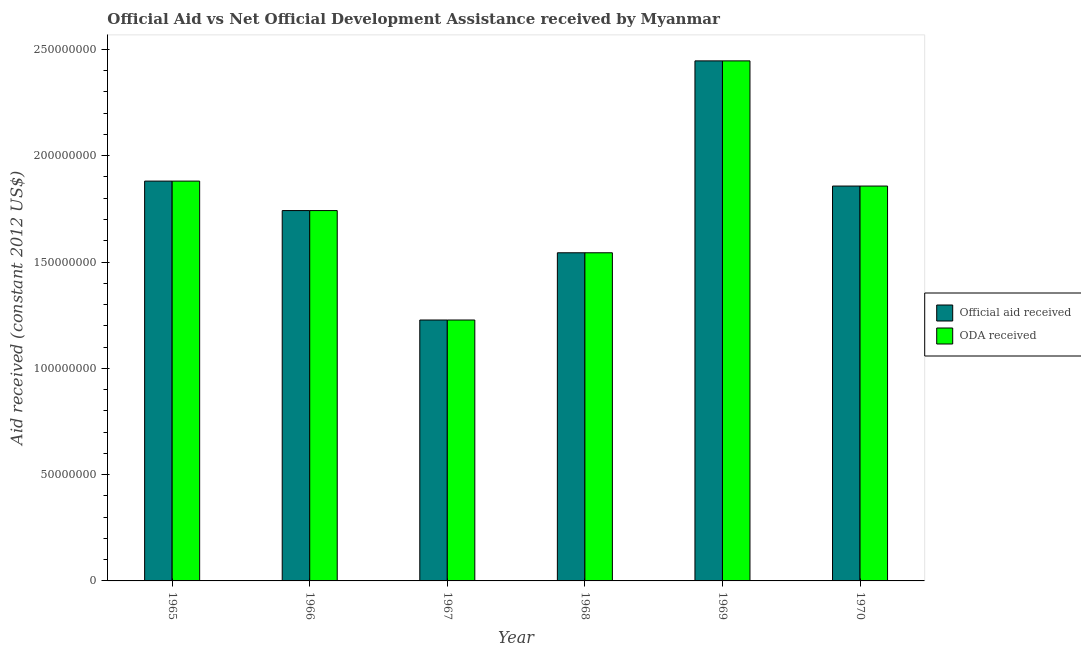How many different coloured bars are there?
Keep it short and to the point. 2. Are the number of bars per tick equal to the number of legend labels?
Your response must be concise. Yes. Are the number of bars on each tick of the X-axis equal?
Your answer should be very brief. Yes. How many bars are there on the 4th tick from the right?
Offer a terse response. 2. What is the label of the 1st group of bars from the left?
Ensure brevity in your answer.  1965. What is the oda received in 1965?
Your answer should be very brief. 1.88e+08. Across all years, what is the maximum official aid received?
Your response must be concise. 2.45e+08. Across all years, what is the minimum official aid received?
Your response must be concise. 1.23e+08. In which year was the official aid received maximum?
Offer a terse response. 1969. In which year was the oda received minimum?
Your answer should be very brief. 1967. What is the total oda received in the graph?
Ensure brevity in your answer.  1.07e+09. What is the difference between the oda received in 1965 and that in 1967?
Your response must be concise. 6.53e+07. What is the difference between the official aid received in 1969 and the oda received in 1967?
Provide a succinct answer. 1.22e+08. What is the average oda received per year?
Make the answer very short. 1.78e+08. In the year 1967, what is the difference between the oda received and official aid received?
Ensure brevity in your answer.  0. In how many years, is the oda received greater than 200000000 US$?
Offer a very short reply. 1. What is the ratio of the oda received in 1967 to that in 1970?
Provide a short and direct response. 0.66. Is the difference between the oda received in 1969 and 1970 greater than the difference between the official aid received in 1969 and 1970?
Keep it short and to the point. No. What is the difference between the highest and the second highest oda received?
Your response must be concise. 5.66e+07. What is the difference between the highest and the lowest official aid received?
Your answer should be compact. 1.22e+08. Is the sum of the oda received in 1966 and 1968 greater than the maximum official aid received across all years?
Keep it short and to the point. Yes. What does the 1st bar from the left in 1966 represents?
Your answer should be very brief. Official aid received. What does the 1st bar from the right in 1969 represents?
Offer a very short reply. ODA received. How many bars are there?
Offer a very short reply. 12. Are all the bars in the graph horizontal?
Provide a succinct answer. No. How many years are there in the graph?
Your answer should be compact. 6. What is the difference between two consecutive major ticks on the Y-axis?
Your answer should be very brief. 5.00e+07. Are the values on the major ticks of Y-axis written in scientific E-notation?
Keep it short and to the point. No. Does the graph contain any zero values?
Your response must be concise. No. Does the graph contain grids?
Make the answer very short. No. How many legend labels are there?
Keep it short and to the point. 2. How are the legend labels stacked?
Offer a terse response. Vertical. What is the title of the graph?
Offer a terse response. Official Aid vs Net Official Development Assistance received by Myanmar . Does "From human activities" appear as one of the legend labels in the graph?
Ensure brevity in your answer.  No. What is the label or title of the X-axis?
Provide a short and direct response. Year. What is the label or title of the Y-axis?
Your answer should be very brief. Aid received (constant 2012 US$). What is the Aid received (constant 2012 US$) in Official aid received in 1965?
Make the answer very short. 1.88e+08. What is the Aid received (constant 2012 US$) in ODA received in 1965?
Provide a short and direct response. 1.88e+08. What is the Aid received (constant 2012 US$) of Official aid received in 1966?
Ensure brevity in your answer.  1.74e+08. What is the Aid received (constant 2012 US$) in ODA received in 1966?
Your answer should be very brief. 1.74e+08. What is the Aid received (constant 2012 US$) of Official aid received in 1967?
Give a very brief answer. 1.23e+08. What is the Aid received (constant 2012 US$) of ODA received in 1967?
Offer a terse response. 1.23e+08. What is the Aid received (constant 2012 US$) of Official aid received in 1968?
Keep it short and to the point. 1.54e+08. What is the Aid received (constant 2012 US$) of ODA received in 1968?
Make the answer very short. 1.54e+08. What is the Aid received (constant 2012 US$) in Official aid received in 1969?
Your response must be concise. 2.45e+08. What is the Aid received (constant 2012 US$) in ODA received in 1969?
Make the answer very short. 2.45e+08. What is the Aid received (constant 2012 US$) in Official aid received in 1970?
Your answer should be compact. 1.86e+08. What is the Aid received (constant 2012 US$) in ODA received in 1970?
Your answer should be very brief. 1.86e+08. Across all years, what is the maximum Aid received (constant 2012 US$) of Official aid received?
Your response must be concise. 2.45e+08. Across all years, what is the maximum Aid received (constant 2012 US$) in ODA received?
Offer a terse response. 2.45e+08. Across all years, what is the minimum Aid received (constant 2012 US$) of Official aid received?
Your answer should be very brief. 1.23e+08. Across all years, what is the minimum Aid received (constant 2012 US$) of ODA received?
Your answer should be very brief. 1.23e+08. What is the total Aid received (constant 2012 US$) in Official aid received in the graph?
Offer a terse response. 1.07e+09. What is the total Aid received (constant 2012 US$) of ODA received in the graph?
Offer a terse response. 1.07e+09. What is the difference between the Aid received (constant 2012 US$) in Official aid received in 1965 and that in 1966?
Give a very brief answer. 1.39e+07. What is the difference between the Aid received (constant 2012 US$) of ODA received in 1965 and that in 1966?
Make the answer very short. 1.39e+07. What is the difference between the Aid received (constant 2012 US$) of Official aid received in 1965 and that in 1967?
Keep it short and to the point. 6.53e+07. What is the difference between the Aid received (constant 2012 US$) of ODA received in 1965 and that in 1967?
Ensure brevity in your answer.  6.53e+07. What is the difference between the Aid received (constant 2012 US$) in Official aid received in 1965 and that in 1968?
Your answer should be compact. 3.37e+07. What is the difference between the Aid received (constant 2012 US$) in ODA received in 1965 and that in 1968?
Give a very brief answer. 3.37e+07. What is the difference between the Aid received (constant 2012 US$) in Official aid received in 1965 and that in 1969?
Ensure brevity in your answer.  -5.66e+07. What is the difference between the Aid received (constant 2012 US$) in ODA received in 1965 and that in 1969?
Offer a very short reply. -5.66e+07. What is the difference between the Aid received (constant 2012 US$) in Official aid received in 1965 and that in 1970?
Your answer should be very brief. 2.33e+06. What is the difference between the Aid received (constant 2012 US$) of ODA received in 1965 and that in 1970?
Ensure brevity in your answer.  2.33e+06. What is the difference between the Aid received (constant 2012 US$) of Official aid received in 1966 and that in 1967?
Provide a succinct answer. 5.15e+07. What is the difference between the Aid received (constant 2012 US$) of ODA received in 1966 and that in 1967?
Give a very brief answer. 5.15e+07. What is the difference between the Aid received (constant 2012 US$) of Official aid received in 1966 and that in 1968?
Your answer should be compact. 1.98e+07. What is the difference between the Aid received (constant 2012 US$) in ODA received in 1966 and that in 1968?
Offer a terse response. 1.98e+07. What is the difference between the Aid received (constant 2012 US$) in Official aid received in 1966 and that in 1969?
Provide a succinct answer. -7.04e+07. What is the difference between the Aid received (constant 2012 US$) in ODA received in 1966 and that in 1969?
Offer a terse response. -7.04e+07. What is the difference between the Aid received (constant 2012 US$) of Official aid received in 1966 and that in 1970?
Offer a terse response. -1.15e+07. What is the difference between the Aid received (constant 2012 US$) of ODA received in 1966 and that in 1970?
Keep it short and to the point. -1.15e+07. What is the difference between the Aid received (constant 2012 US$) in Official aid received in 1967 and that in 1968?
Offer a terse response. -3.16e+07. What is the difference between the Aid received (constant 2012 US$) of ODA received in 1967 and that in 1968?
Give a very brief answer. -3.16e+07. What is the difference between the Aid received (constant 2012 US$) in Official aid received in 1967 and that in 1969?
Offer a very short reply. -1.22e+08. What is the difference between the Aid received (constant 2012 US$) of ODA received in 1967 and that in 1969?
Provide a short and direct response. -1.22e+08. What is the difference between the Aid received (constant 2012 US$) of Official aid received in 1967 and that in 1970?
Your answer should be compact. -6.30e+07. What is the difference between the Aid received (constant 2012 US$) in ODA received in 1967 and that in 1970?
Your response must be concise. -6.30e+07. What is the difference between the Aid received (constant 2012 US$) in Official aid received in 1968 and that in 1969?
Offer a very short reply. -9.03e+07. What is the difference between the Aid received (constant 2012 US$) of ODA received in 1968 and that in 1969?
Your answer should be very brief. -9.03e+07. What is the difference between the Aid received (constant 2012 US$) in Official aid received in 1968 and that in 1970?
Ensure brevity in your answer.  -3.14e+07. What is the difference between the Aid received (constant 2012 US$) in ODA received in 1968 and that in 1970?
Your answer should be very brief. -3.14e+07. What is the difference between the Aid received (constant 2012 US$) of Official aid received in 1969 and that in 1970?
Give a very brief answer. 5.89e+07. What is the difference between the Aid received (constant 2012 US$) of ODA received in 1969 and that in 1970?
Provide a short and direct response. 5.89e+07. What is the difference between the Aid received (constant 2012 US$) of Official aid received in 1965 and the Aid received (constant 2012 US$) of ODA received in 1966?
Give a very brief answer. 1.39e+07. What is the difference between the Aid received (constant 2012 US$) of Official aid received in 1965 and the Aid received (constant 2012 US$) of ODA received in 1967?
Offer a very short reply. 6.53e+07. What is the difference between the Aid received (constant 2012 US$) in Official aid received in 1965 and the Aid received (constant 2012 US$) in ODA received in 1968?
Keep it short and to the point. 3.37e+07. What is the difference between the Aid received (constant 2012 US$) in Official aid received in 1965 and the Aid received (constant 2012 US$) in ODA received in 1969?
Keep it short and to the point. -5.66e+07. What is the difference between the Aid received (constant 2012 US$) in Official aid received in 1965 and the Aid received (constant 2012 US$) in ODA received in 1970?
Ensure brevity in your answer.  2.33e+06. What is the difference between the Aid received (constant 2012 US$) of Official aid received in 1966 and the Aid received (constant 2012 US$) of ODA received in 1967?
Make the answer very short. 5.15e+07. What is the difference between the Aid received (constant 2012 US$) of Official aid received in 1966 and the Aid received (constant 2012 US$) of ODA received in 1968?
Make the answer very short. 1.98e+07. What is the difference between the Aid received (constant 2012 US$) in Official aid received in 1966 and the Aid received (constant 2012 US$) in ODA received in 1969?
Ensure brevity in your answer.  -7.04e+07. What is the difference between the Aid received (constant 2012 US$) of Official aid received in 1966 and the Aid received (constant 2012 US$) of ODA received in 1970?
Make the answer very short. -1.15e+07. What is the difference between the Aid received (constant 2012 US$) of Official aid received in 1967 and the Aid received (constant 2012 US$) of ODA received in 1968?
Make the answer very short. -3.16e+07. What is the difference between the Aid received (constant 2012 US$) of Official aid received in 1967 and the Aid received (constant 2012 US$) of ODA received in 1969?
Your answer should be compact. -1.22e+08. What is the difference between the Aid received (constant 2012 US$) in Official aid received in 1967 and the Aid received (constant 2012 US$) in ODA received in 1970?
Keep it short and to the point. -6.30e+07. What is the difference between the Aid received (constant 2012 US$) in Official aid received in 1968 and the Aid received (constant 2012 US$) in ODA received in 1969?
Give a very brief answer. -9.03e+07. What is the difference between the Aid received (constant 2012 US$) in Official aid received in 1968 and the Aid received (constant 2012 US$) in ODA received in 1970?
Ensure brevity in your answer.  -3.14e+07. What is the difference between the Aid received (constant 2012 US$) in Official aid received in 1969 and the Aid received (constant 2012 US$) in ODA received in 1970?
Ensure brevity in your answer.  5.89e+07. What is the average Aid received (constant 2012 US$) in Official aid received per year?
Your response must be concise. 1.78e+08. What is the average Aid received (constant 2012 US$) of ODA received per year?
Keep it short and to the point. 1.78e+08. In the year 1967, what is the difference between the Aid received (constant 2012 US$) of Official aid received and Aid received (constant 2012 US$) of ODA received?
Offer a terse response. 0. What is the ratio of the Aid received (constant 2012 US$) in Official aid received in 1965 to that in 1966?
Your answer should be very brief. 1.08. What is the ratio of the Aid received (constant 2012 US$) in ODA received in 1965 to that in 1966?
Your response must be concise. 1.08. What is the ratio of the Aid received (constant 2012 US$) in Official aid received in 1965 to that in 1967?
Give a very brief answer. 1.53. What is the ratio of the Aid received (constant 2012 US$) in ODA received in 1965 to that in 1967?
Your answer should be compact. 1.53. What is the ratio of the Aid received (constant 2012 US$) in Official aid received in 1965 to that in 1968?
Ensure brevity in your answer.  1.22. What is the ratio of the Aid received (constant 2012 US$) of ODA received in 1965 to that in 1968?
Your answer should be very brief. 1.22. What is the ratio of the Aid received (constant 2012 US$) of Official aid received in 1965 to that in 1969?
Offer a very short reply. 0.77. What is the ratio of the Aid received (constant 2012 US$) of ODA received in 1965 to that in 1969?
Offer a very short reply. 0.77. What is the ratio of the Aid received (constant 2012 US$) of Official aid received in 1965 to that in 1970?
Offer a very short reply. 1.01. What is the ratio of the Aid received (constant 2012 US$) of ODA received in 1965 to that in 1970?
Provide a succinct answer. 1.01. What is the ratio of the Aid received (constant 2012 US$) in Official aid received in 1966 to that in 1967?
Give a very brief answer. 1.42. What is the ratio of the Aid received (constant 2012 US$) in ODA received in 1966 to that in 1967?
Offer a terse response. 1.42. What is the ratio of the Aid received (constant 2012 US$) in Official aid received in 1966 to that in 1968?
Make the answer very short. 1.13. What is the ratio of the Aid received (constant 2012 US$) in ODA received in 1966 to that in 1968?
Your answer should be very brief. 1.13. What is the ratio of the Aid received (constant 2012 US$) in Official aid received in 1966 to that in 1969?
Your answer should be very brief. 0.71. What is the ratio of the Aid received (constant 2012 US$) of ODA received in 1966 to that in 1969?
Offer a terse response. 0.71. What is the ratio of the Aid received (constant 2012 US$) in Official aid received in 1966 to that in 1970?
Offer a terse response. 0.94. What is the ratio of the Aid received (constant 2012 US$) of ODA received in 1966 to that in 1970?
Your answer should be very brief. 0.94. What is the ratio of the Aid received (constant 2012 US$) of Official aid received in 1967 to that in 1968?
Your answer should be compact. 0.8. What is the ratio of the Aid received (constant 2012 US$) in ODA received in 1967 to that in 1968?
Ensure brevity in your answer.  0.8. What is the ratio of the Aid received (constant 2012 US$) in Official aid received in 1967 to that in 1969?
Give a very brief answer. 0.5. What is the ratio of the Aid received (constant 2012 US$) in ODA received in 1967 to that in 1969?
Keep it short and to the point. 0.5. What is the ratio of the Aid received (constant 2012 US$) of Official aid received in 1967 to that in 1970?
Offer a terse response. 0.66. What is the ratio of the Aid received (constant 2012 US$) in ODA received in 1967 to that in 1970?
Make the answer very short. 0.66. What is the ratio of the Aid received (constant 2012 US$) in Official aid received in 1968 to that in 1969?
Provide a short and direct response. 0.63. What is the ratio of the Aid received (constant 2012 US$) in ODA received in 1968 to that in 1969?
Ensure brevity in your answer.  0.63. What is the ratio of the Aid received (constant 2012 US$) of Official aid received in 1968 to that in 1970?
Offer a very short reply. 0.83. What is the ratio of the Aid received (constant 2012 US$) in ODA received in 1968 to that in 1970?
Make the answer very short. 0.83. What is the ratio of the Aid received (constant 2012 US$) of Official aid received in 1969 to that in 1970?
Your answer should be compact. 1.32. What is the ratio of the Aid received (constant 2012 US$) of ODA received in 1969 to that in 1970?
Give a very brief answer. 1.32. What is the difference between the highest and the second highest Aid received (constant 2012 US$) of Official aid received?
Provide a short and direct response. 5.66e+07. What is the difference between the highest and the second highest Aid received (constant 2012 US$) of ODA received?
Provide a succinct answer. 5.66e+07. What is the difference between the highest and the lowest Aid received (constant 2012 US$) in Official aid received?
Give a very brief answer. 1.22e+08. What is the difference between the highest and the lowest Aid received (constant 2012 US$) of ODA received?
Provide a succinct answer. 1.22e+08. 